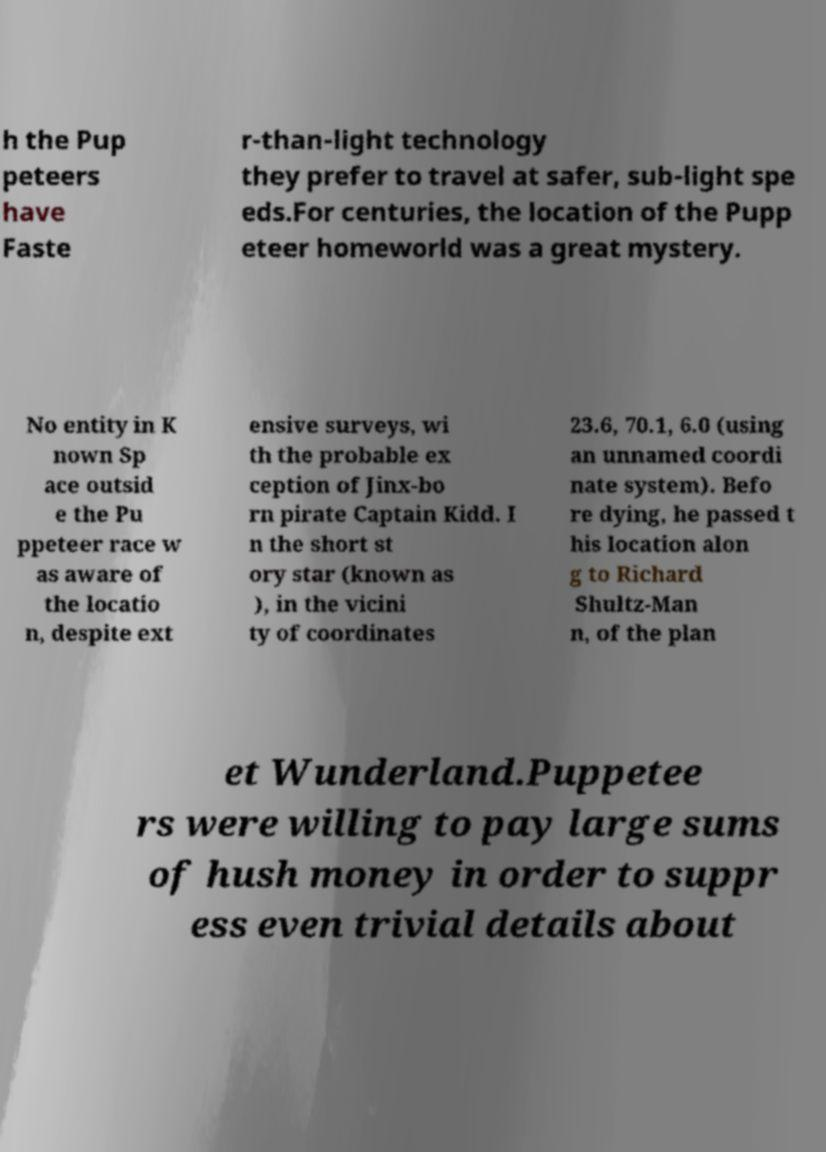Could you extract and type out the text from this image? h the Pup peteers have Faste r-than-light technology they prefer to travel at safer, sub-light spe eds.For centuries, the location of the Pupp eteer homeworld was a great mystery. No entity in K nown Sp ace outsid e the Pu ppeteer race w as aware of the locatio n, despite ext ensive surveys, wi th the probable ex ception of Jinx-bo rn pirate Captain Kidd. I n the short st ory star (known as ), in the vicini ty of coordinates 23.6, 70.1, 6.0 (using an unnamed coordi nate system). Befo re dying, he passed t his location alon g to Richard Shultz-Man n, of the plan et Wunderland.Puppetee rs were willing to pay large sums of hush money in order to suppr ess even trivial details about 